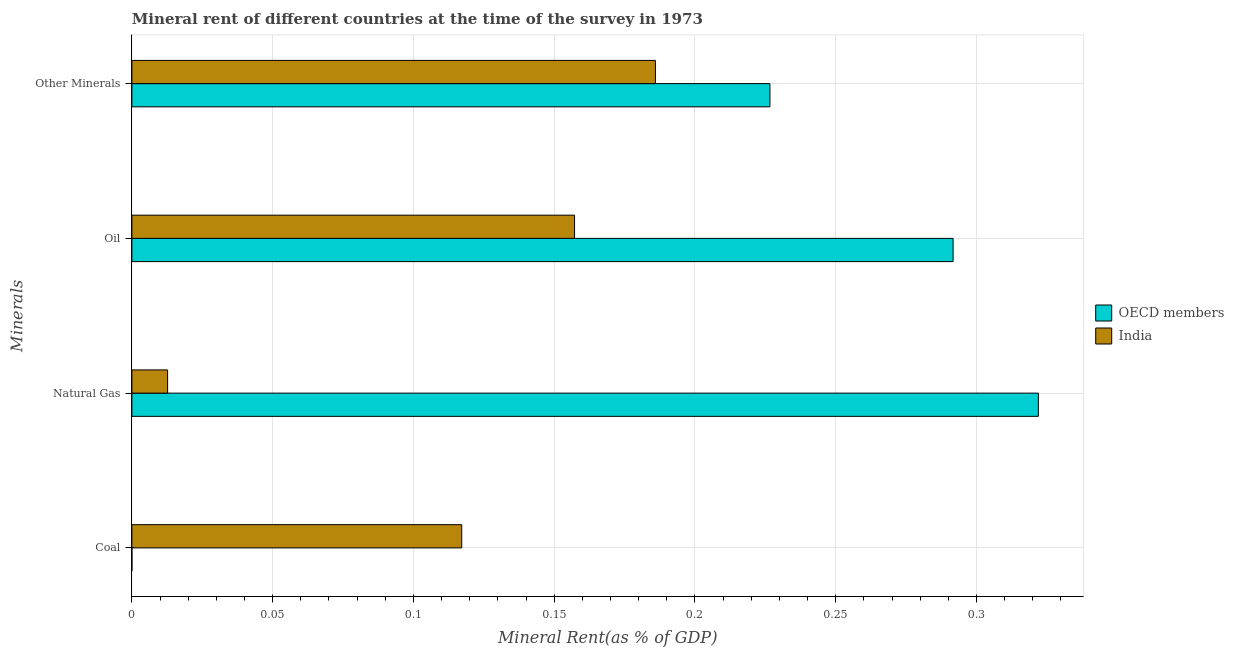How many different coloured bars are there?
Provide a succinct answer. 2. How many groups of bars are there?
Make the answer very short. 4. Are the number of bars per tick equal to the number of legend labels?
Offer a very short reply. Yes. Are the number of bars on each tick of the Y-axis equal?
Keep it short and to the point. Yes. What is the label of the 2nd group of bars from the top?
Keep it short and to the point. Oil. What is the  rent of other minerals in India?
Offer a terse response. 0.19. Across all countries, what is the maximum  rent of other minerals?
Your answer should be very brief. 0.23. Across all countries, what is the minimum coal rent?
Make the answer very short. 1.50641686702978e-6. In which country was the oil rent minimum?
Your answer should be compact. India. What is the total  rent of other minerals in the graph?
Offer a very short reply. 0.41. What is the difference between the coal rent in India and that in OECD members?
Make the answer very short. 0.12. What is the difference between the natural gas rent in India and the coal rent in OECD members?
Offer a terse response. 0.01. What is the average oil rent per country?
Offer a very short reply. 0.22. What is the difference between the oil rent and natural gas rent in India?
Provide a short and direct response. 0.14. What is the ratio of the oil rent in India to that in OECD members?
Provide a short and direct response. 0.54. Is the difference between the coal rent in India and OECD members greater than the difference between the  rent of other minerals in India and OECD members?
Your response must be concise. Yes. What is the difference between the highest and the second highest oil rent?
Your response must be concise. 0.13. What is the difference between the highest and the lowest natural gas rent?
Offer a terse response. 0.31. Is the sum of the  rent of other minerals in OECD members and India greater than the maximum natural gas rent across all countries?
Give a very brief answer. Yes. Is it the case that in every country, the sum of the oil rent and coal rent is greater than the sum of natural gas rent and  rent of other minerals?
Ensure brevity in your answer.  No. Is it the case that in every country, the sum of the coal rent and natural gas rent is greater than the oil rent?
Ensure brevity in your answer.  No. Are all the bars in the graph horizontal?
Your answer should be compact. Yes. How many countries are there in the graph?
Provide a succinct answer. 2. Does the graph contain grids?
Ensure brevity in your answer.  Yes. How many legend labels are there?
Your answer should be very brief. 2. What is the title of the graph?
Provide a short and direct response. Mineral rent of different countries at the time of the survey in 1973. What is the label or title of the X-axis?
Your response must be concise. Mineral Rent(as % of GDP). What is the label or title of the Y-axis?
Your answer should be very brief. Minerals. What is the Mineral Rent(as % of GDP) of OECD members in Coal?
Your response must be concise. 1.50641686702978e-6. What is the Mineral Rent(as % of GDP) of India in Coal?
Provide a succinct answer. 0.12. What is the Mineral Rent(as % of GDP) of OECD members in Natural Gas?
Provide a short and direct response. 0.32. What is the Mineral Rent(as % of GDP) of India in Natural Gas?
Your answer should be very brief. 0.01. What is the Mineral Rent(as % of GDP) of OECD members in Oil?
Ensure brevity in your answer.  0.29. What is the Mineral Rent(as % of GDP) of India in Oil?
Offer a terse response. 0.16. What is the Mineral Rent(as % of GDP) in OECD members in Other Minerals?
Your answer should be very brief. 0.23. What is the Mineral Rent(as % of GDP) in India in Other Minerals?
Offer a terse response. 0.19. Across all Minerals, what is the maximum Mineral Rent(as % of GDP) of OECD members?
Provide a succinct answer. 0.32. Across all Minerals, what is the maximum Mineral Rent(as % of GDP) of India?
Offer a terse response. 0.19. Across all Minerals, what is the minimum Mineral Rent(as % of GDP) in OECD members?
Your answer should be compact. 1.50641686702978e-6. Across all Minerals, what is the minimum Mineral Rent(as % of GDP) in India?
Make the answer very short. 0.01. What is the total Mineral Rent(as % of GDP) in OECD members in the graph?
Provide a succinct answer. 0.84. What is the total Mineral Rent(as % of GDP) of India in the graph?
Offer a terse response. 0.47. What is the difference between the Mineral Rent(as % of GDP) of OECD members in Coal and that in Natural Gas?
Keep it short and to the point. -0.32. What is the difference between the Mineral Rent(as % of GDP) of India in Coal and that in Natural Gas?
Provide a short and direct response. 0.1. What is the difference between the Mineral Rent(as % of GDP) in OECD members in Coal and that in Oil?
Your answer should be compact. -0.29. What is the difference between the Mineral Rent(as % of GDP) of India in Coal and that in Oil?
Offer a terse response. -0.04. What is the difference between the Mineral Rent(as % of GDP) in OECD members in Coal and that in Other Minerals?
Provide a succinct answer. -0.23. What is the difference between the Mineral Rent(as % of GDP) in India in Coal and that in Other Minerals?
Keep it short and to the point. -0.07. What is the difference between the Mineral Rent(as % of GDP) in OECD members in Natural Gas and that in Oil?
Offer a very short reply. 0.03. What is the difference between the Mineral Rent(as % of GDP) of India in Natural Gas and that in Oil?
Your answer should be compact. -0.14. What is the difference between the Mineral Rent(as % of GDP) of OECD members in Natural Gas and that in Other Minerals?
Your response must be concise. 0.1. What is the difference between the Mineral Rent(as % of GDP) in India in Natural Gas and that in Other Minerals?
Keep it short and to the point. -0.17. What is the difference between the Mineral Rent(as % of GDP) in OECD members in Oil and that in Other Minerals?
Provide a succinct answer. 0.07. What is the difference between the Mineral Rent(as % of GDP) in India in Oil and that in Other Minerals?
Provide a short and direct response. -0.03. What is the difference between the Mineral Rent(as % of GDP) of OECD members in Coal and the Mineral Rent(as % of GDP) of India in Natural Gas?
Offer a terse response. -0.01. What is the difference between the Mineral Rent(as % of GDP) of OECD members in Coal and the Mineral Rent(as % of GDP) of India in Oil?
Provide a short and direct response. -0.16. What is the difference between the Mineral Rent(as % of GDP) of OECD members in Coal and the Mineral Rent(as % of GDP) of India in Other Minerals?
Your answer should be very brief. -0.19. What is the difference between the Mineral Rent(as % of GDP) in OECD members in Natural Gas and the Mineral Rent(as % of GDP) in India in Oil?
Make the answer very short. 0.16. What is the difference between the Mineral Rent(as % of GDP) of OECD members in Natural Gas and the Mineral Rent(as % of GDP) of India in Other Minerals?
Your answer should be very brief. 0.14. What is the difference between the Mineral Rent(as % of GDP) of OECD members in Oil and the Mineral Rent(as % of GDP) of India in Other Minerals?
Give a very brief answer. 0.11. What is the average Mineral Rent(as % of GDP) in OECD members per Minerals?
Your response must be concise. 0.21. What is the average Mineral Rent(as % of GDP) of India per Minerals?
Provide a short and direct response. 0.12. What is the difference between the Mineral Rent(as % of GDP) of OECD members and Mineral Rent(as % of GDP) of India in Coal?
Ensure brevity in your answer.  -0.12. What is the difference between the Mineral Rent(as % of GDP) in OECD members and Mineral Rent(as % of GDP) in India in Natural Gas?
Your answer should be compact. 0.31. What is the difference between the Mineral Rent(as % of GDP) in OECD members and Mineral Rent(as % of GDP) in India in Oil?
Keep it short and to the point. 0.13. What is the difference between the Mineral Rent(as % of GDP) in OECD members and Mineral Rent(as % of GDP) in India in Other Minerals?
Your response must be concise. 0.04. What is the ratio of the Mineral Rent(as % of GDP) of OECD members in Coal to that in Natural Gas?
Ensure brevity in your answer.  0. What is the ratio of the Mineral Rent(as % of GDP) in India in Coal to that in Natural Gas?
Ensure brevity in your answer.  9.23. What is the ratio of the Mineral Rent(as % of GDP) in India in Coal to that in Oil?
Your answer should be very brief. 0.75. What is the ratio of the Mineral Rent(as % of GDP) of India in Coal to that in Other Minerals?
Provide a short and direct response. 0.63. What is the ratio of the Mineral Rent(as % of GDP) of OECD members in Natural Gas to that in Oil?
Keep it short and to the point. 1.1. What is the ratio of the Mineral Rent(as % of GDP) of India in Natural Gas to that in Oil?
Keep it short and to the point. 0.08. What is the ratio of the Mineral Rent(as % of GDP) of OECD members in Natural Gas to that in Other Minerals?
Your answer should be very brief. 1.42. What is the ratio of the Mineral Rent(as % of GDP) in India in Natural Gas to that in Other Minerals?
Keep it short and to the point. 0.07. What is the ratio of the Mineral Rent(as % of GDP) in OECD members in Oil to that in Other Minerals?
Offer a very short reply. 1.29. What is the ratio of the Mineral Rent(as % of GDP) of India in Oil to that in Other Minerals?
Provide a succinct answer. 0.85. What is the difference between the highest and the second highest Mineral Rent(as % of GDP) in OECD members?
Offer a terse response. 0.03. What is the difference between the highest and the second highest Mineral Rent(as % of GDP) of India?
Provide a succinct answer. 0.03. What is the difference between the highest and the lowest Mineral Rent(as % of GDP) of OECD members?
Your answer should be compact. 0.32. What is the difference between the highest and the lowest Mineral Rent(as % of GDP) of India?
Your answer should be very brief. 0.17. 